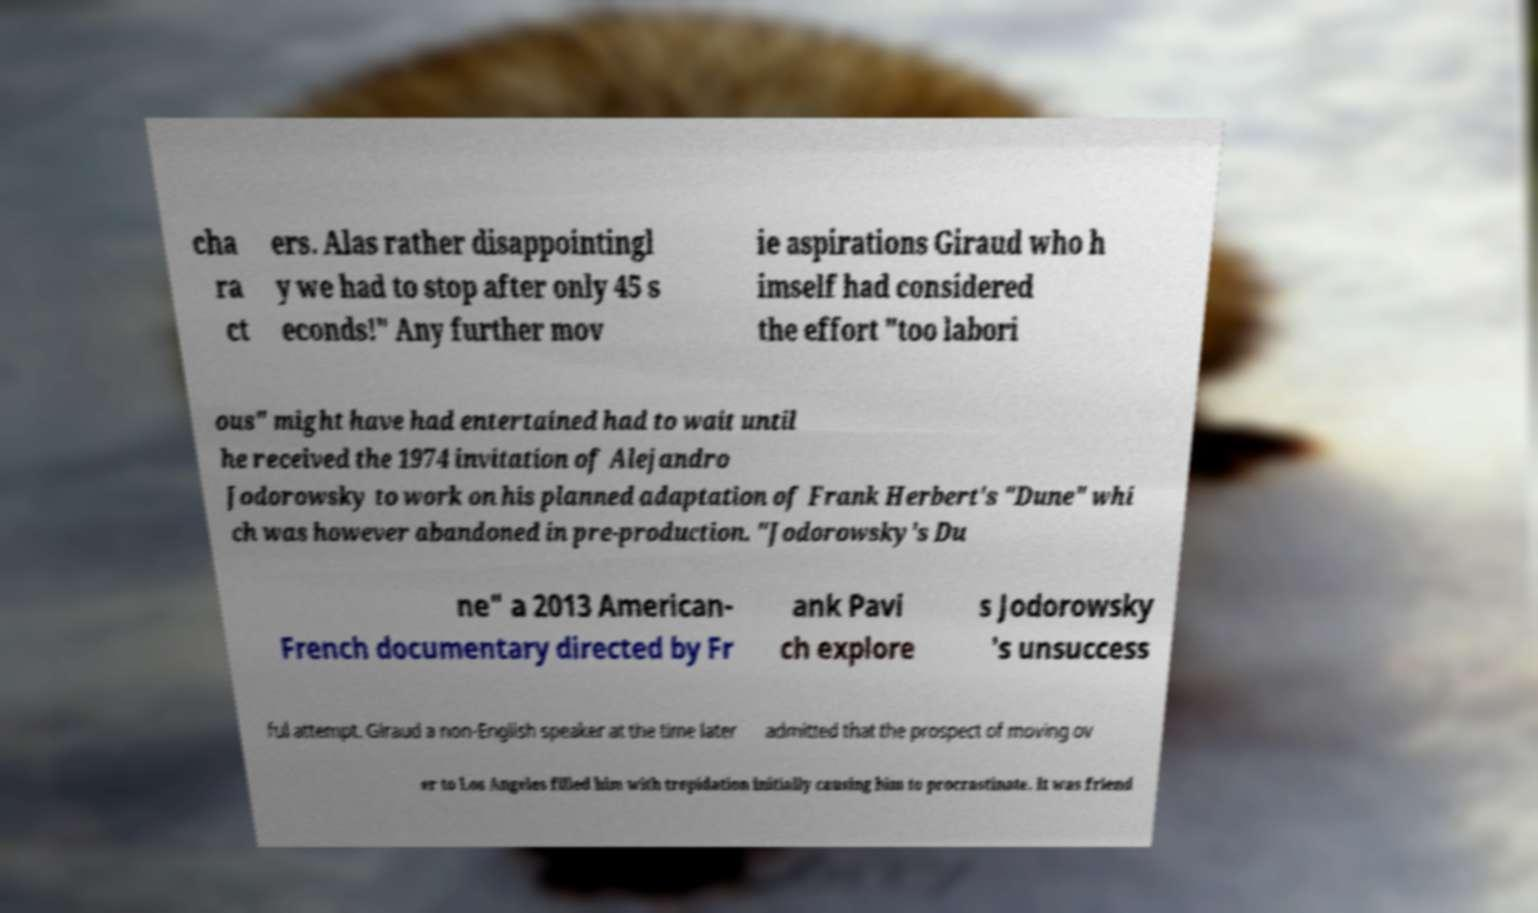I need the written content from this picture converted into text. Can you do that? cha ra ct ers. Alas rather disappointingl y we had to stop after only 45 s econds!" Any further mov ie aspirations Giraud who h imself had considered the effort "too labori ous" might have had entertained had to wait until he received the 1974 invitation of Alejandro Jodorowsky to work on his planned adaptation of Frank Herbert's "Dune" whi ch was however abandoned in pre-production. "Jodorowsky's Du ne" a 2013 American- French documentary directed by Fr ank Pavi ch explore s Jodorowsky 's unsuccess ful attempt. Giraud a non-English speaker at the time later admitted that the prospect of moving ov er to Los Angeles filled him with trepidation initially causing him to procrastinate. It was friend 